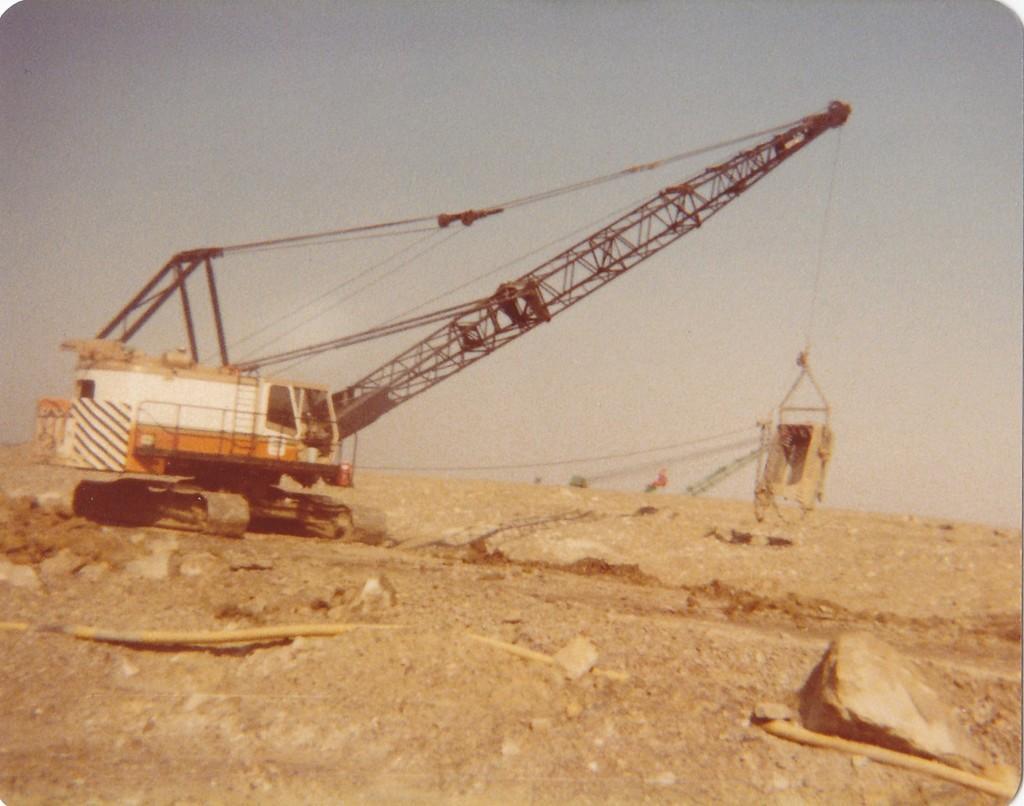Could you give a brief overview of what you see in this image? In this image we can see a crane on the ground, there are some stones and wires, in the background, we can see the sky. 